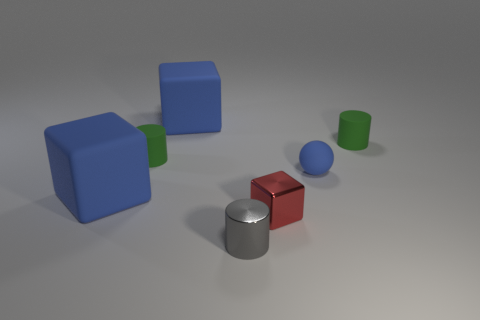Is there a red rubber object of the same size as the red metallic object?
Provide a succinct answer. No. What number of blue rubber objects have the same size as the shiny cube?
Your answer should be compact. 1. Are there fewer small gray objects that are behind the blue ball than small rubber things that are on the right side of the gray metallic cylinder?
Make the answer very short. Yes. What is the size of the blue sphere that is on the right side of the tiny rubber cylinder that is on the left side of the blue rubber thing that is right of the tiny red metal thing?
Provide a short and direct response. Small. How big is the cylinder that is left of the small blue object and behind the gray cylinder?
Your answer should be very brief. Small. What shape is the metallic object that is to the right of the tiny metal thing in front of the small red shiny thing?
Ensure brevity in your answer.  Cube. Are there any other things that are the same color as the ball?
Ensure brevity in your answer.  Yes. What is the shape of the tiny object on the right side of the blue rubber ball?
Keep it short and to the point. Cylinder. What is the shape of the object that is in front of the small blue rubber object and behind the small red metallic thing?
Offer a very short reply. Cube. What number of blue things are cubes or small shiny cubes?
Your response must be concise. 2. 